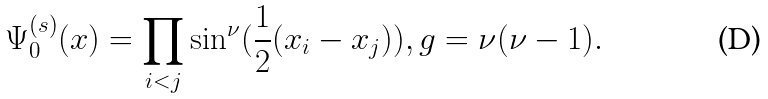Convert formula to latex. <formula><loc_0><loc_0><loc_500><loc_500>\Psi _ { 0 } ^ { ( s ) } ( x ) = \prod _ { i < j } \sin ^ { \nu } ( \frac { 1 } { 2 } ( x _ { i } - x _ { j } ) ) , g = \nu ( \nu - 1 ) .</formula> 